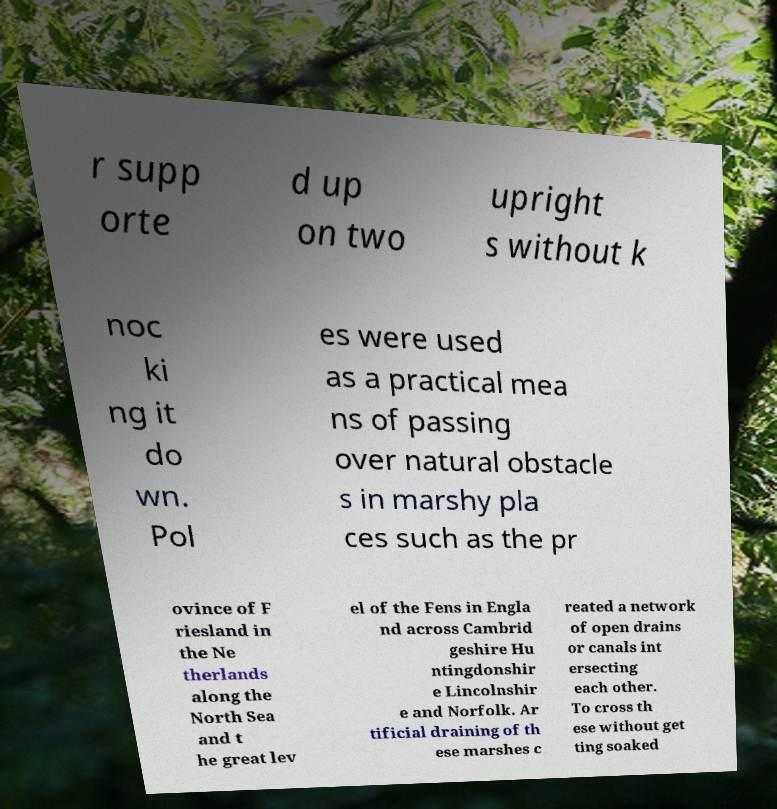I need the written content from this picture converted into text. Can you do that? r supp orte d up on two upright s without k noc ki ng it do wn. Pol es were used as a practical mea ns of passing over natural obstacle s in marshy pla ces such as the pr ovince of F riesland in the Ne therlands along the North Sea and t he great lev el of the Fens in Engla nd across Cambrid geshire Hu ntingdonshir e Lincolnshir e and Norfolk. Ar tificial draining of th ese marshes c reated a network of open drains or canals int ersecting each other. To cross th ese without get ting soaked 